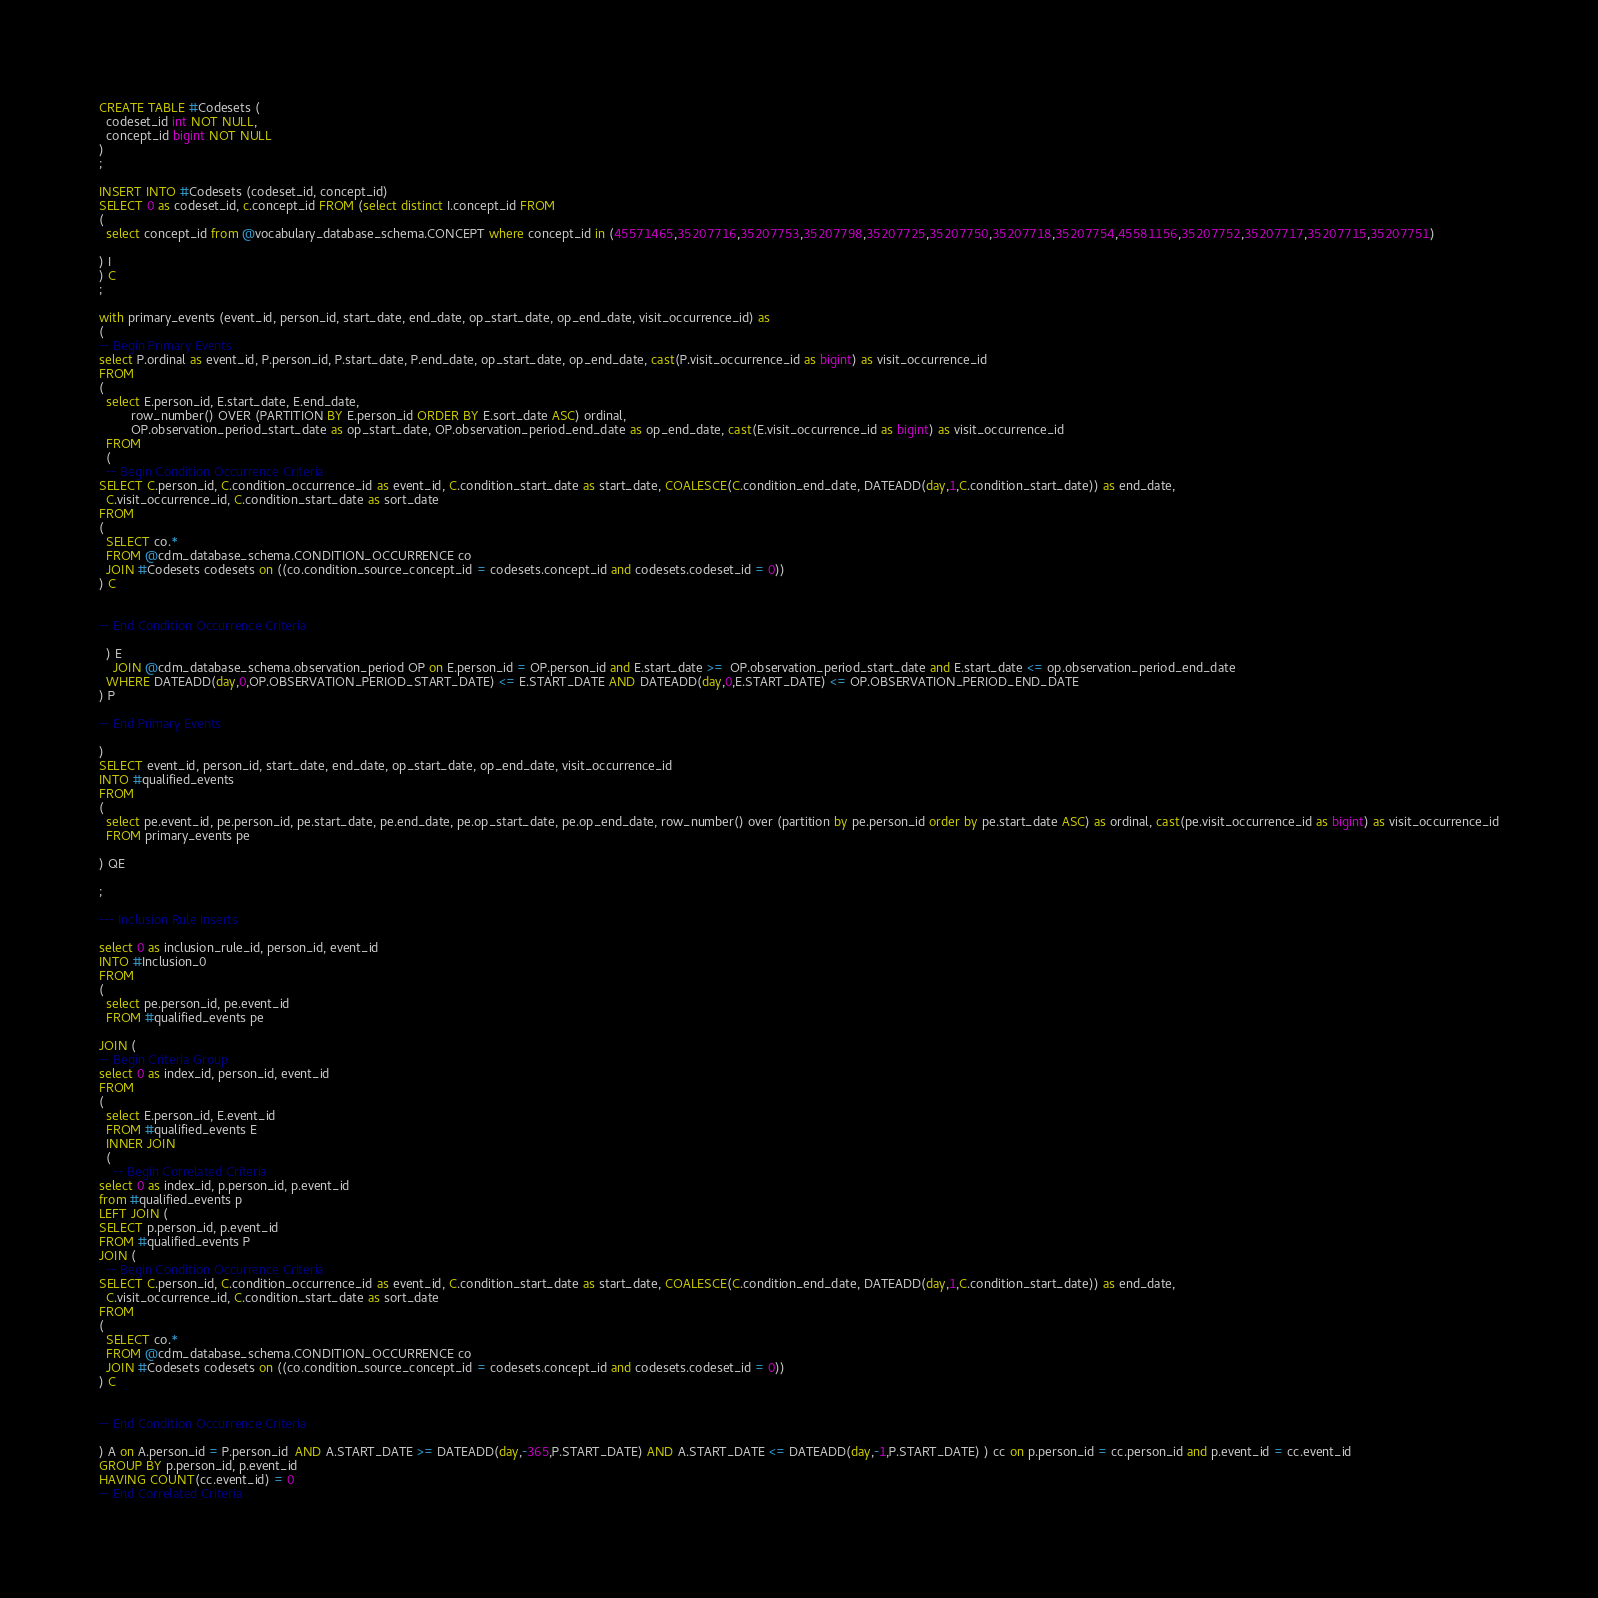<code> <loc_0><loc_0><loc_500><loc_500><_SQL_>CREATE TABLE #Codesets (
  codeset_id int NOT NULL,
  concept_id bigint NOT NULL
)
;

INSERT INTO #Codesets (codeset_id, concept_id)
SELECT 0 as codeset_id, c.concept_id FROM (select distinct I.concept_id FROM
( 
  select concept_id from @vocabulary_database_schema.CONCEPT where concept_id in (45571465,35207716,35207753,35207798,35207725,35207750,35207718,35207754,45581156,35207752,35207717,35207715,35207751)

) I
) C
;

with primary_events (event_id, person_id, start_date, end_date, op_start_date, op_end_date, visit_occurrence_id) as
(
-- Begin Primary Events
select P.ordinal as event_id, P.person_id, P.start_date, P.end_date, op_start_date, op_end_date, cast(P.visit_occurrence_id as bigint) as visit_occurrence_id
FROM
(
  select E.person_id, E.start_date, E.end_date,
         row_number() OVER (PARTITION BY E.person_id ORDER BY E.sort_date ASC) ordinal,
         OP.observation_period_start_date as op_start_date, OP.observation_period_end_date as op_end_date, cast(E.visit_occurrence_id as bigint) as visit_occurrence_id
  FROM 
  (
  -- Begin Condition Occurrence Criteria
SELECT C.person_id, C.condition_occurrence_id as event_id, C.condition_start_date as start_date, COALESCE(C.condition_end_date, DATEADD(day,1,C.condition_start_date)) as end_date,
  C.visit_occurrence_id, C.condition_start_date as sort_date
FROM 
(
  SELECT co.* 
  FROM @cdm_database_schema.CONDITION_OCCURRENCE co
  JOIN #Codesets codesets on ((co.condition_source_concept_id = codesets.concept_id and codesets.codeset_id = 0))
) C


-- End Condition Occurrence Criteria

  ) E
	JOIN @cdm_database_schema.observation_period OP on E.person_id = OP.person_id and E.start_date >=  OP.observation_period_start_date and E.start_date <= op.observation_period_end_date
  WHERE DATEADD(day,0,OP.OBSERVATION_PERIOD_START_DATE) <= E.START_DATE AND DATEADD(day,0,E.START_DATE) <= OP.OBSERVATION_PERIOD_END_DATE
) P

-- End Primary Events

)
SELECT event_id, person_id, start_date, end_date, op_start_date, op_end_date, visit_occurrence_id
INTO #qualified_events
FROM 
(
  select pe.event_id, pe.person_id, pe.start_date, pe.end_date, pe.op_start_date, pe.op_end_date, row_number() over (partition by pe.person_id order by pe.start_date ASC) as ordinal, cast(pe.visit_occurrence_id as bigint) as visit_occurrence_id
  FROM primary_events pe
  
) QE

;

--- Inclusion Rule Inserts

select 0 as inclusion_rule_id, person_id, event_id
INTO #Inclusion_0
FROM 
(
  select pe.person_id, pe.event_id
  FROM #qualified_events pe
  
JOIN (
-- Begin Criteria Group
select 0 as index_id, person_id, event_id
FROM
(
  select E.person_id, E.event_id 
  FROM #qualified_events E
  INNER JOIN
  (
    -- Begin Correlated Criteria
select 0 as index_id, p.person_id, p.event_id
from #qualified_events p
LEFT JOIN (
SELECT p.person_id, p.event_id 
FROM #qualified_events P
JOIN (
  -- Begin Condition Occurrence Criteria
SELECT C.person_id, C.condition_occurrence_id as event_id, C.condition_start_date as start_date, COALESCE(C.condition_end_date, DATEADD(day,1,C.condition_start_date)) as end_date,
  C.visit_occurrence_id, C.condition_start_date as sort_date
FROM 
(
  SELECT co.* 
  FROM @cdm_database_schema.CONDITION_OCCURRENCE co
  JOIN #Codesets codesets on ((co.condition_source_concept_id = codesets.concept_id and codesets.codeset_id = 0))
) C


-- End Condition Occurrence Criteria

) A on A.person_id = P.person_id  AND A.START_DATE >= DATEADD(day,-365,P.START_DATE) AND A.START_DATE <= DATEADD(day,-1,P.START_DATE) ) cc on p.person_id = cc.person_id and p.event_id = cc.event_id
GROUP BY p.person_id, p.event_id
HAVING COUNT(cc.event_id) = 0
-- End Correlated Criteria
</code> 